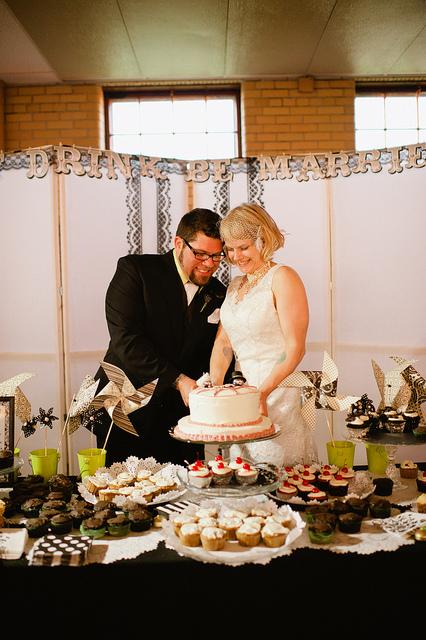Who has a white dress on?
Write a very short answer. Bride. Is this a big celebration?
Be succinct. Yes. What is the event?
Be succinct. Wedding. 